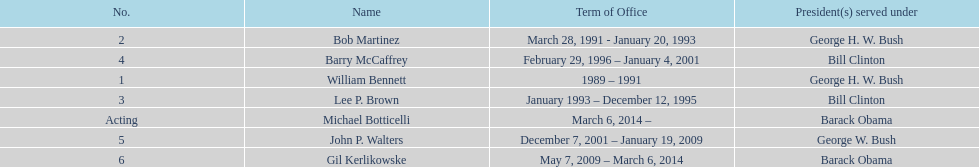What were the total number of years bob martinez served in office? 2. 